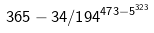<formula> <loc_0><loc_0><loc_500><loc_500>3 6 5 - 3 4 / 1 9 4 ^ { 4 7 3 - 5 ^ { 3 2 3 } }</formula> 